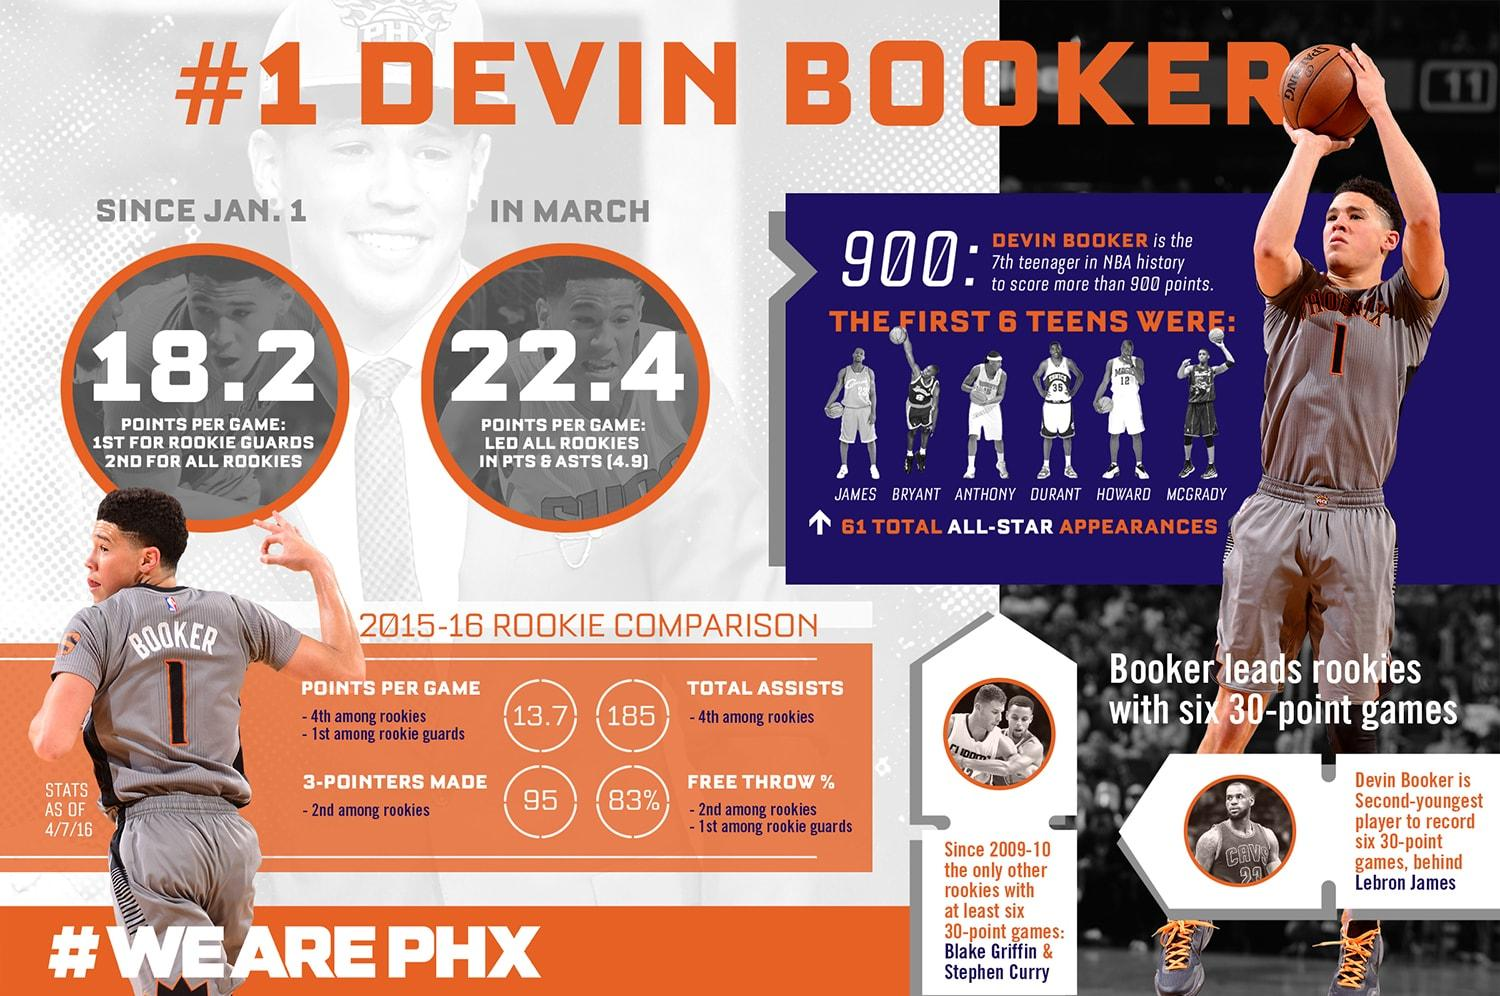Mention a couple of crucial points in this snapshot. Please identify the player with jersey number 12, who is named Howard. Devin Booker played for the Phoenix Suns. Devin Booker, a rookie guard, stood out among his peers by earning the highest points per game average while also having the second highest free throw percentage among all rookie guards. 